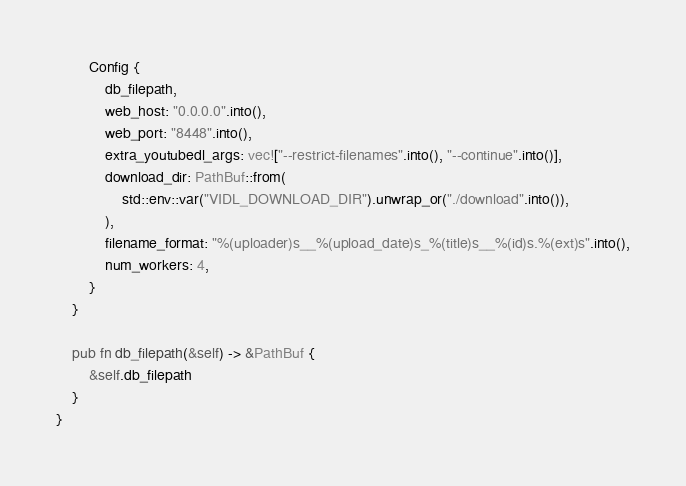Convert code to text. <code><loc_0><loc_0><loc_500><loc_500><_Rust_>        Config {
            db_filepath,
            web_host: "0.0.0.0".into(),
            web_port: "8448".into(),
            extra_youtubedl_args: vec!["--restrict-filenames".into(), "--continue".into()],
            download_dir: PathBuf::from(
                std::env::var("VIDL_DOWNLOAD_DIR").unwrap_or("./download".into()),
            ),
            filename_format: "%(uploader)s__%(upload_date)s_%(title)s__%(id)s.%(ext)s".into(),
            num_workers: 4,
        }
    }

    pub fn db_filepath(&self) -> &PathBuf {
        &self.db_filepath
    }
}
</code> 